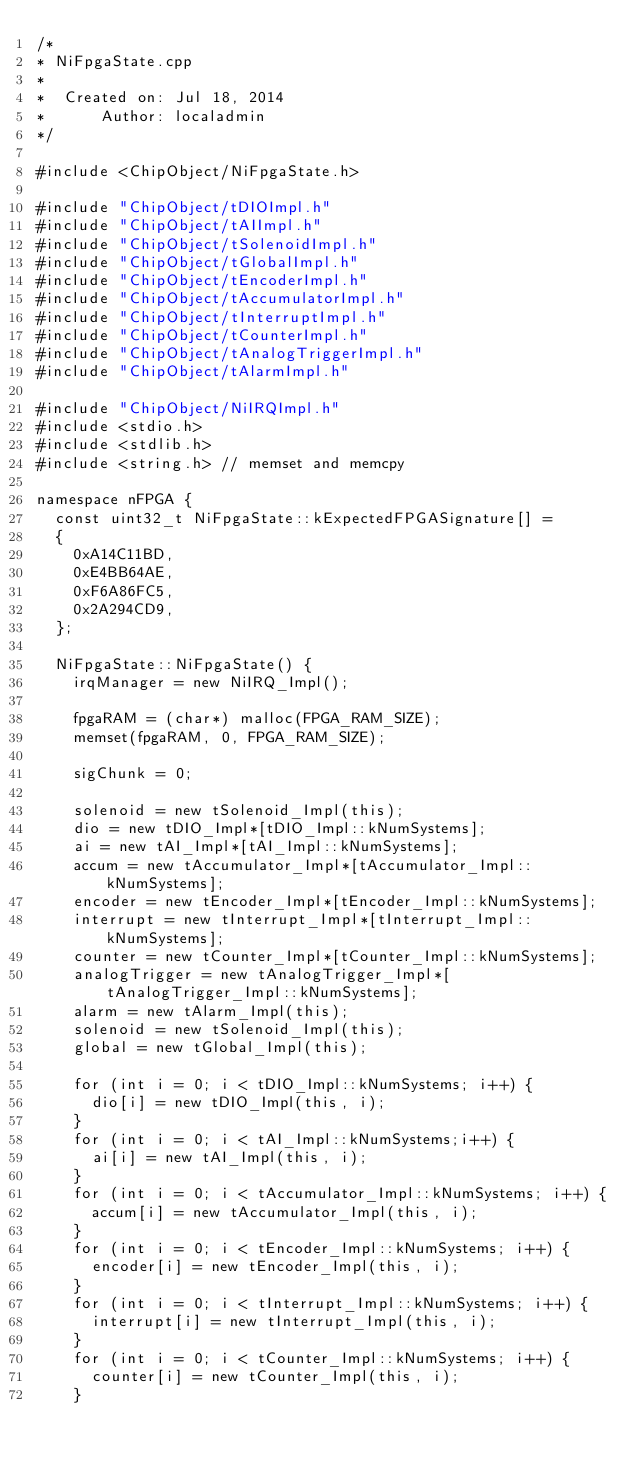Convert code to text. <code><loc_0><loc_0><loc_500><loc_500><_C++_>/*
* NiFpgaState.cpp
*
*  Created on: Jul 18, 2014
*      Author: localadmin
*/

#include <ChipObject/NiFpgaState.h>

#include "ChipObject/tDIOImpl.h"
#include "ChipObject/tAIImpl.h"
#include "ChipObject/tSolenoidImpl.h"
#include "ChipObject/tGlobalImpl.h"
#include "ChipObject/tEncoderImpl.h"
#include "ChipObject/tAccumulatorImpl.h"
#include "ChipObject/tInterruptImpl.h"
#include "ChipObject/tCounterImpl.h"
#include "ChipObject/tAnalogTriggerImpl.h"
#include "ChipObject/tAlarmImpl.h"

#include "ChipObject/NiIRQImpl.h"
#include <stdio.h>
#include <stdlib.h>
#include <string.h> // memset and memcpy

namespace nFPGA {
	const uint32_t NiFpgaState::kExpectedFPGASignature[] =
	{
		0xA14C11BD,
		0xE4BB64AE,
		0xF6A86FC5,
		0x2A294CD9,
	};

	NiFpgaState::NiFpgaState() {
		irqManager = new NiIRQ_Impl();

		fpgaRAM = (char*) malloc(FPGA_RAM_SIZE);
		memset(fpgaRAM, 0, FPGA_RAM_SIZE);

		sigChunk = 0;

		solenoid = new tSolenoid_Impl(this);
		dio = new tDIO_Impl*[tDIO_Impl::kNumSystems];
		ai = new tAI_Impl*[tAI_Impl::kNumSystems];
		accum = new tAccumulator_Impl*[tAccumulator_Impl::kNumSystems];
		encoder = new tEncoder_Impl*[tEncoder_Impl::kNumSystems];
		interrupt = new tInterrupt_Impl*[tInterrupt_Impl::kNumSystems];
		counter = new tCounter_Impl*[tCounter_Impl::kNumSystems];
		analogTrigger = new tAnalogTrigger_Impl*[tAnalogTrigger_Impl::kNumSystems];
		alarm = new tAlarm_Impl(this);
		solenoid = new tSolenoid_Impl(this);
		global = new tGlobal_Impl(this);

		for (int i = 0; i < tDIO_Impl::kNumSystems; i++) {
			dio[i] = new tDIO_Impl(this, i);
		}
		for (int i = 0; i < tAI_Impl::kNumSystems;i++) {
			ai[i] = new tAI_Impl(this, i);
		}
		for (int i = 0; i < tAccumulator_Impl::kNumSystems; i++) {
			accum[i] = new tAccumulator_Impl(this, i);
		}
		for (int i = 0; i < tEncoder_Impl::kNumSystems; i++) {
			encoder[i] = new tEncoder_Impl(this, i);
		}
		for (int i = 0; i < tInterrupt_Impl::kNumSystems; i++) {
			interrupt[i] = new tInterrupt_Impl(this, i);
		}
		for (int i = 0; i < tCounter_Impl::kNumSystems; i++) {
			counter[i] = new tCounter_Impl(this, i);
		}</code> 